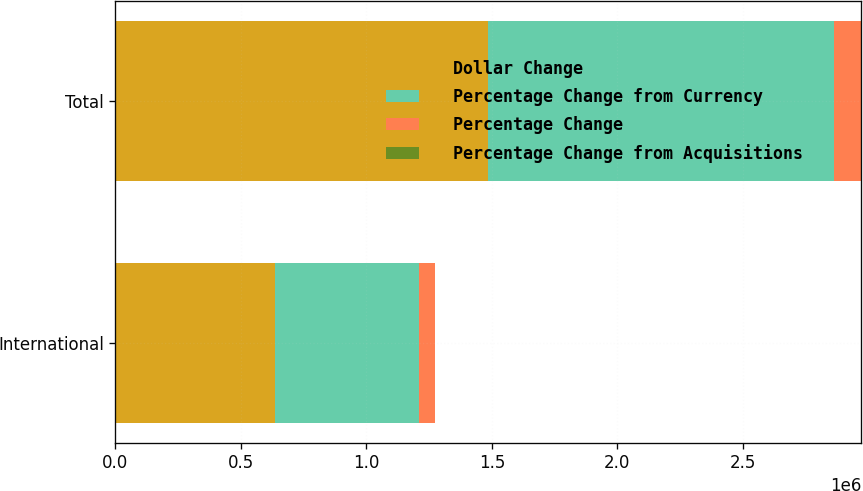Convert chart to OTSL. <chart><loc_0><loc_0><loc_500><loc_500><stacked_bar_chart><ecel><fcel>International<fcel>Total<nl><fcel>Dollar Change<fcel>636882<fcel>1.48581e+06<nl><fcel>Percentage Change from Currency<fcel>574712<fcel>1.37706e+06<nl><fcel>Percentage Change<fcel>62170<fcel>108749<nl><fcel>Percentage Change from Acquisitions<fcel>10.8<fcel>7.9<nl></chart> 